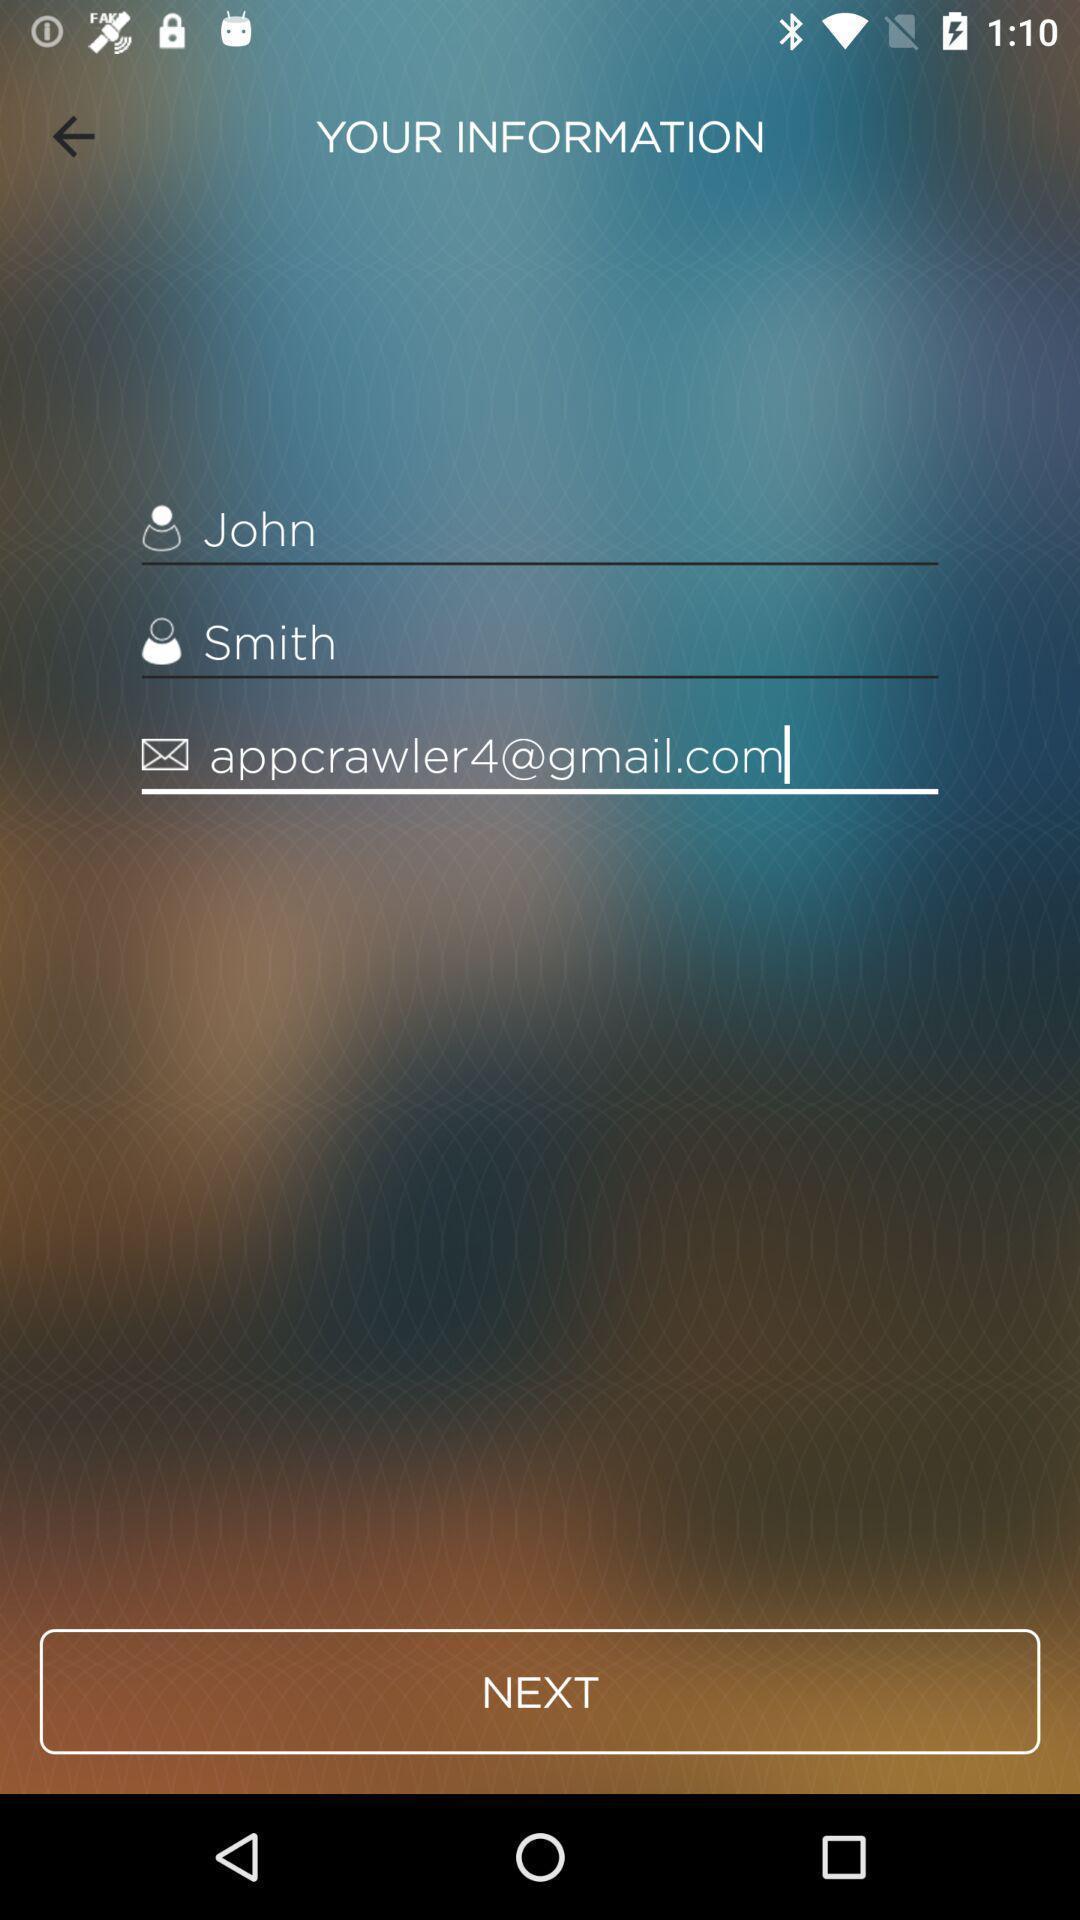Summarize the main components in this picture. Sign-up page for an application. 